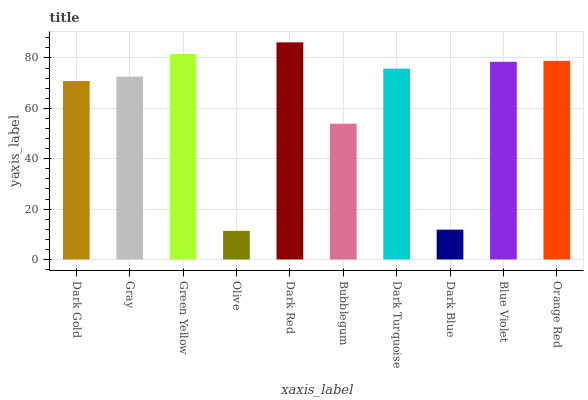Is Olive the minimum?
Answer yes or no. Yes. Is Dark Red the maximum?
Answer yes or no. Yes. Is Gray the minimum?
Answer yes or no. No. Is Gray the maximum?
Answer yes or no. No. Is Gray greater than Dark Gold?
Answer yes or no. Yes. Is Dark Gold less than Gray?
Answer yes or no. Yes. Is Dark Gold greater than Gray?
Answer yes or no. No. Is Gray less than Dark Gold?
Answer yes or no. No. Is Dark Turquoise the high median?
Answer yes or no. Yes. Is Gray the low median?
Answer yes or no. Yes. Is Green Yellow the high median?
Answer yes or no. No. Is Dark Turquoise the low median?
Answer yes or no. No. 